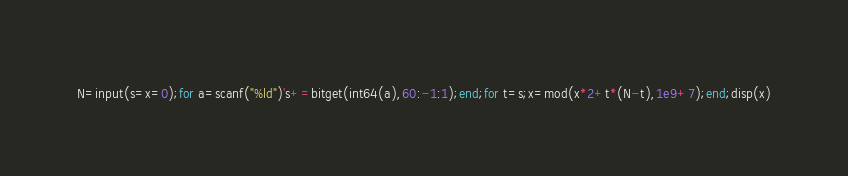Convert code to text. <code><loc_0><loc_0><loc_500><loc_500><_Octave_>N=input(s=x=0);for a=scanf("%ld")'s+=bitget(int64(a),60:-1:1);end;for t=s;x=mod(x*2+t*(N-t),1e9+7);end;disp(x)</code> 